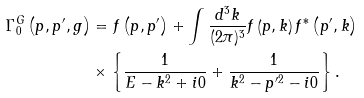<formula> <loc_0><loc_0><loc_500><loc_500>\Gamma _ { 0 } ^ { G } \left ( { p } , { p } ^ { \prime } , g \right ) & = f \left ( { p } , { p } ^ { \prime } \right ) + \int \frac { d ^ { 3 } { k } } { ( 2 \pi ) ^ { 3 } } f \left ( { p } , { k } \right ) f ^ { * } \left ( { p } ^ { \prime } , { k } \right ) \\ & \times \left \{ \frac { 1 } { E - { k } ^ { 2 } + i 0 } + \frac { 1 } { { k } ^ { 2 } - { p } ^ { \prime 2 } - i 0 } \right \} .</formula> 